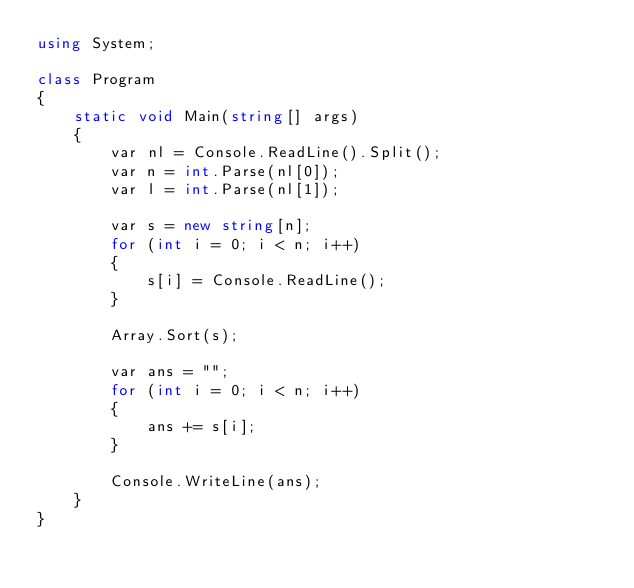Convert code to text. <code><loc_0><loc_0><loc_500><loc_500><_C#_>using System;

class Program
{
    static void Main(string[] args)
    {
        var nl = Console.ReadLine().Split();
        var n = int.Parse(nl[0]);
        var l = int.Parse(nl[1]);

        var s = new string[n];
        for (int i = 0; i < n; i++)
        {
            s[i] = Console.ReadLine();
        }

        Array.Sort(s);

        var ans = "";
        for (int i = 0; i < n; i++)
        {
            ans += s[i];
        }

        Console.WriteLine(ans);
    }
}
</code> 